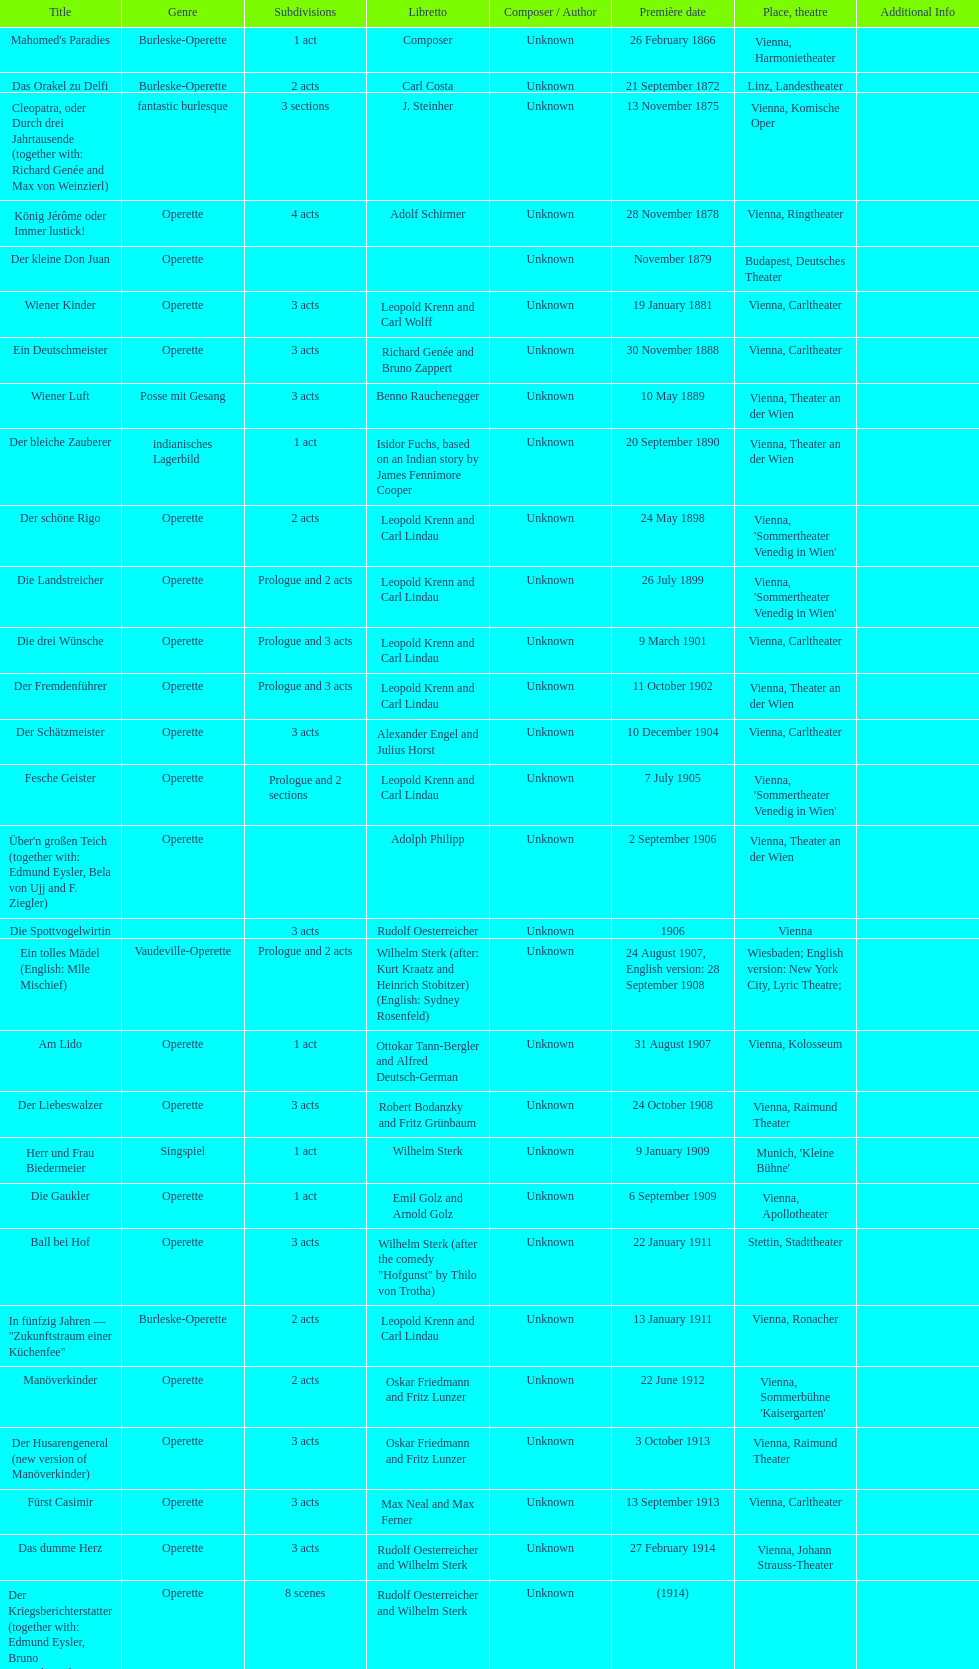How many of his operettas were 3 acts? 13. 